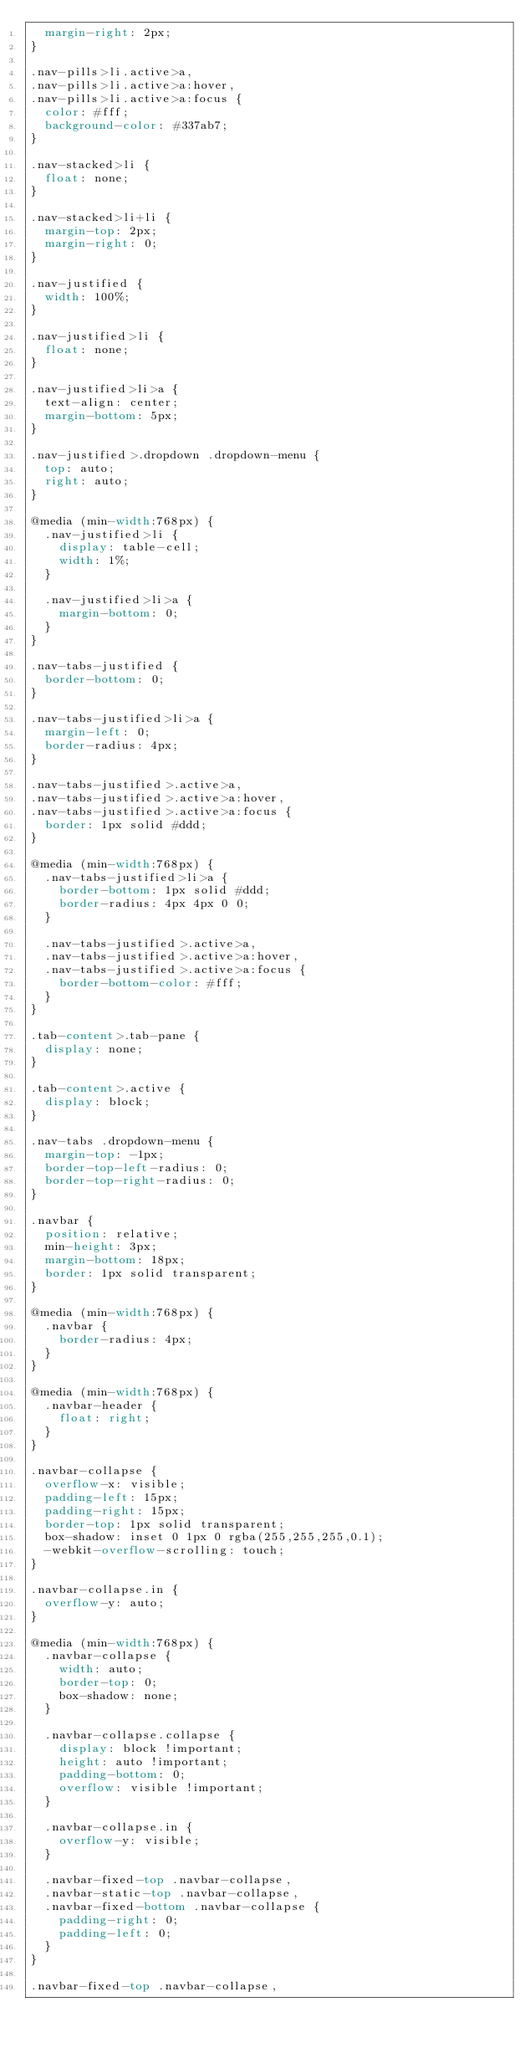Convert code to text. <code><loc_0><loc_0><loc_500><loc_500><_CSS_>  margin-right: 2px;
}

.nav-pills>li.active>a,
.nav-pills>li.active>a:hover,
.nav-pills>li.active>a:focus {
  color: #fff;
  background-color: #337ab7;
}

.nav-stacked>li {
  float: none;
}

.nav-stacked>li+li {
  margin-top: 2px;
  margin-right: 0;
}

.nav-justified {
  width: 100%;
}

.nav-justified>li {
  float: none;
}

.nav-justified>li>a {
  text-align: center;
  margin-bottom: 5px;
}

.nav-justified>.dropdown .dropdown-menu {
  top: auto;
  right: auto;
}

@media (min-width:768px) {
  .nav-justified>li {
    display: table-cell;
    width: 1%;
  }

  .nav-justified>li>a {
    margin-bottom: 0;
  }
}

.nav-tabs-justified {
  border-bottom: 0;
}

.nav-tabs-justified>li>a {
  margin-left: 0;
  border-radius: 4px;
}

.nav-tabs-justified>.active>a,
.nav-tabs-justified>.active>a:hover,
.nav-tabs-justified>.active>a:focus {
  border: 1px solid #ddd;
}

@media (min-width:768px) {
  .nav-tabs-justified>li>a {
    border-bottom: 1px solid #ddd;
    border-radius: 4px 4px 0 0;
  }

  .nav-tabs-justified>.active>a,
  .nav-tabs-justified>.active>a:hover,
  .nav-tabs-justified>.active>a:focus {
    border-bottom-color: #fff;
  }
}

.tab-content>.tab-pane {
  display: none;
}

.tab-content>.active {
  display: block;
}

.nav-tabs .dropdown-menu {
  margin-top: -1px;
  border-top-left-radius: 0;
  border-top-right-radius: 0;
}

.navbar {
  position: relative;
  min-height: 3px;
  margin-bottom: 18px;
  border: 1px solid transparent;
}

@media (min-width:768px) {
  .navbar {
    border-radius: 4px;
  }
}

@media (min-width:768px) {
  .navbar-header {
    float: right;
  }
}

.navbar-collapse {
  overflow-x: visible;
  padding-left: 15px;
  padding-right: 15px;
  border-top: 1px solid transparent;
  box-shadow: inset 0 1px 0 rgba(255,255,255,0.1);
  -webkit-overflow-scrolling: touch;
}

.navbar-collapse.in {
  overflow-y: auto;
}

@media (min-width:768px) {
  .navbar-collapse {
    width: auto;
    border-top: 0;
    box-shadow: none;
  }

  .navbar-collapse.collapse {
    display: block !important;
    height: auto !important;
    padding-bottom: 0;
    overflow: visible !important;
  }

  .navbar-collapse.in {
    overflow-y: visible;
  }

  .navbar-fixed-top .navbar-collapse,
  .navbar-static-top .navbar-collapse,
  .navbar-fixed-bottom .navbar-collapse {
    padding-right: 0;
    padding-left: 0;
  }
}

.navbar-fixed-top .navbar-collapse,</code> 